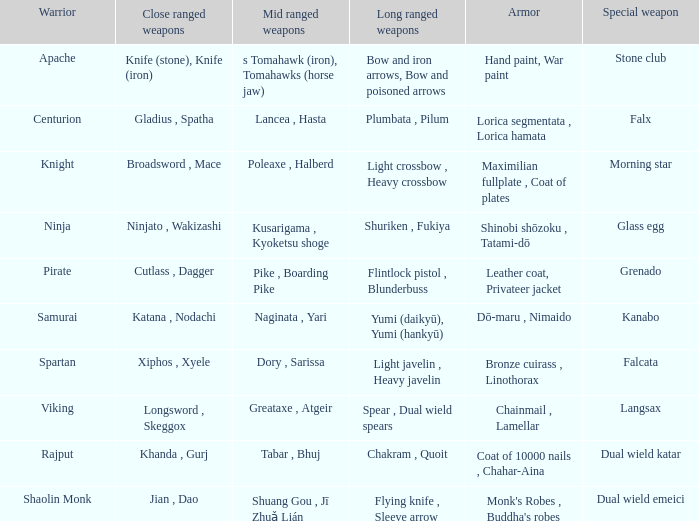If the armor is bronze cuirass , linothorax, what are the close ranged weapons? Xiphos , Xyele. 